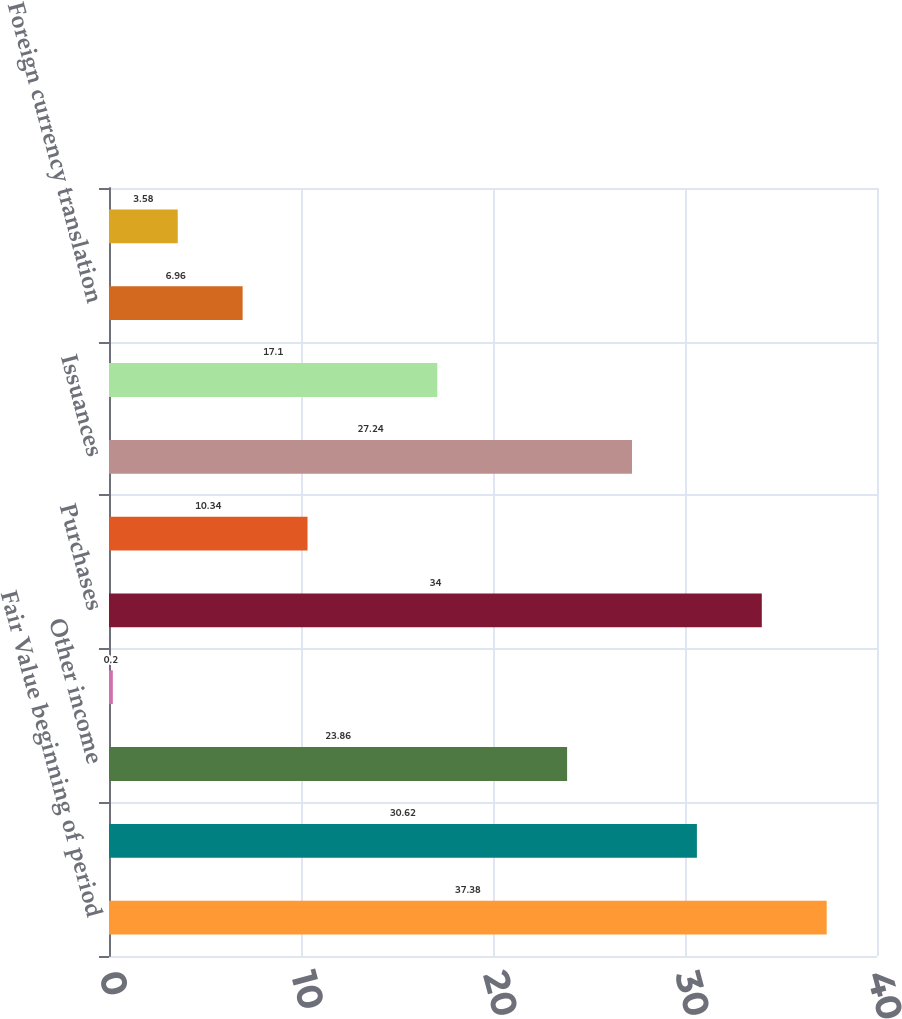Convert chart. <chart><loc_0><loc_0><loc_500><loc_500><bar_chart><fcel>Fair Value beginning of period<fcel>Realized investment gains<fcel>Other income<fcel>Net investment income<fcel>Purchases<fcel>Sales<fcel>Issuances<fcel>Settlements<fcel>Foreign currency translation<fcel>Other(1)<nl><fcel>37.38<fcel>30.62<fcel>23.86<fcel>0.2<fcel>34<fcel>10.34<fcel>27.24<fcel>17.1<fcel>6.96<fcel>3.58<nl></chart> 